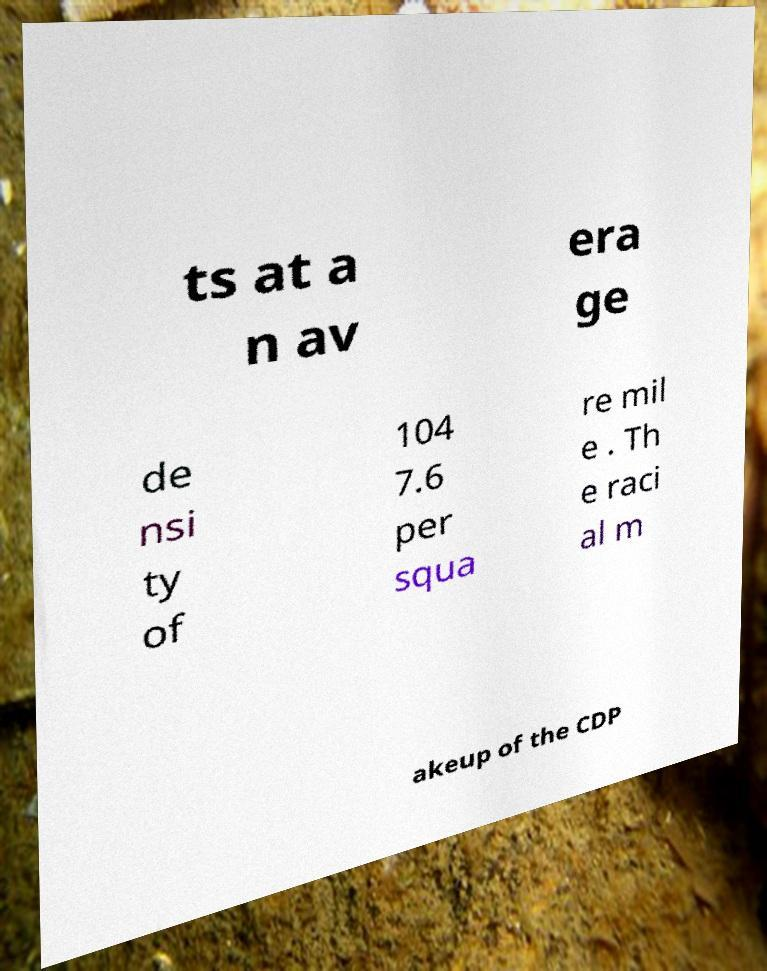Can you read and provide the text displayed in the image?This photo seems to have some interesting text. Can you extract and type it out for me? ts at a n av era ge de nsi ty of 104 7.6 per squa re mil e . Th e raci al m akeup of the CDP 